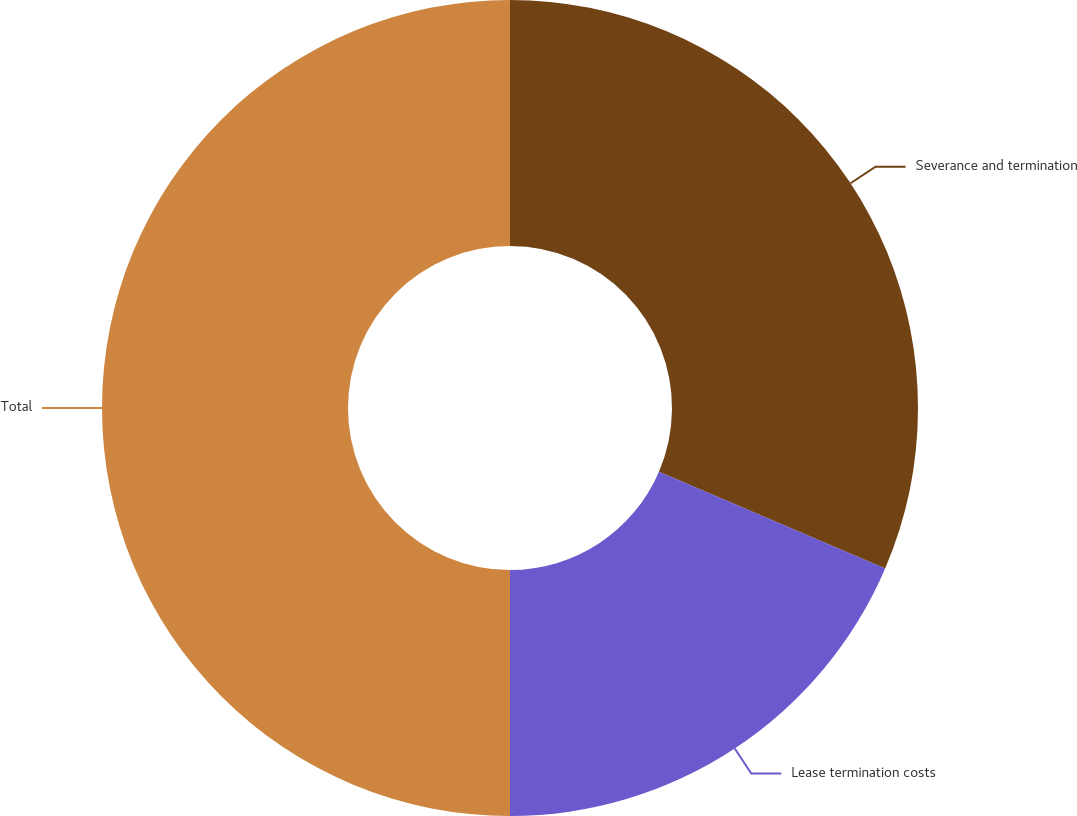Convert chart. <chart><loc_0><loc_0><loc_500><loc_500><pie_chart><fcel>Severance and termination<fcel>Lease termination costs<fcel>Total<nl><fcel>31.43%<fcel>18.57%<fcel>50.0%<nl></chart> 